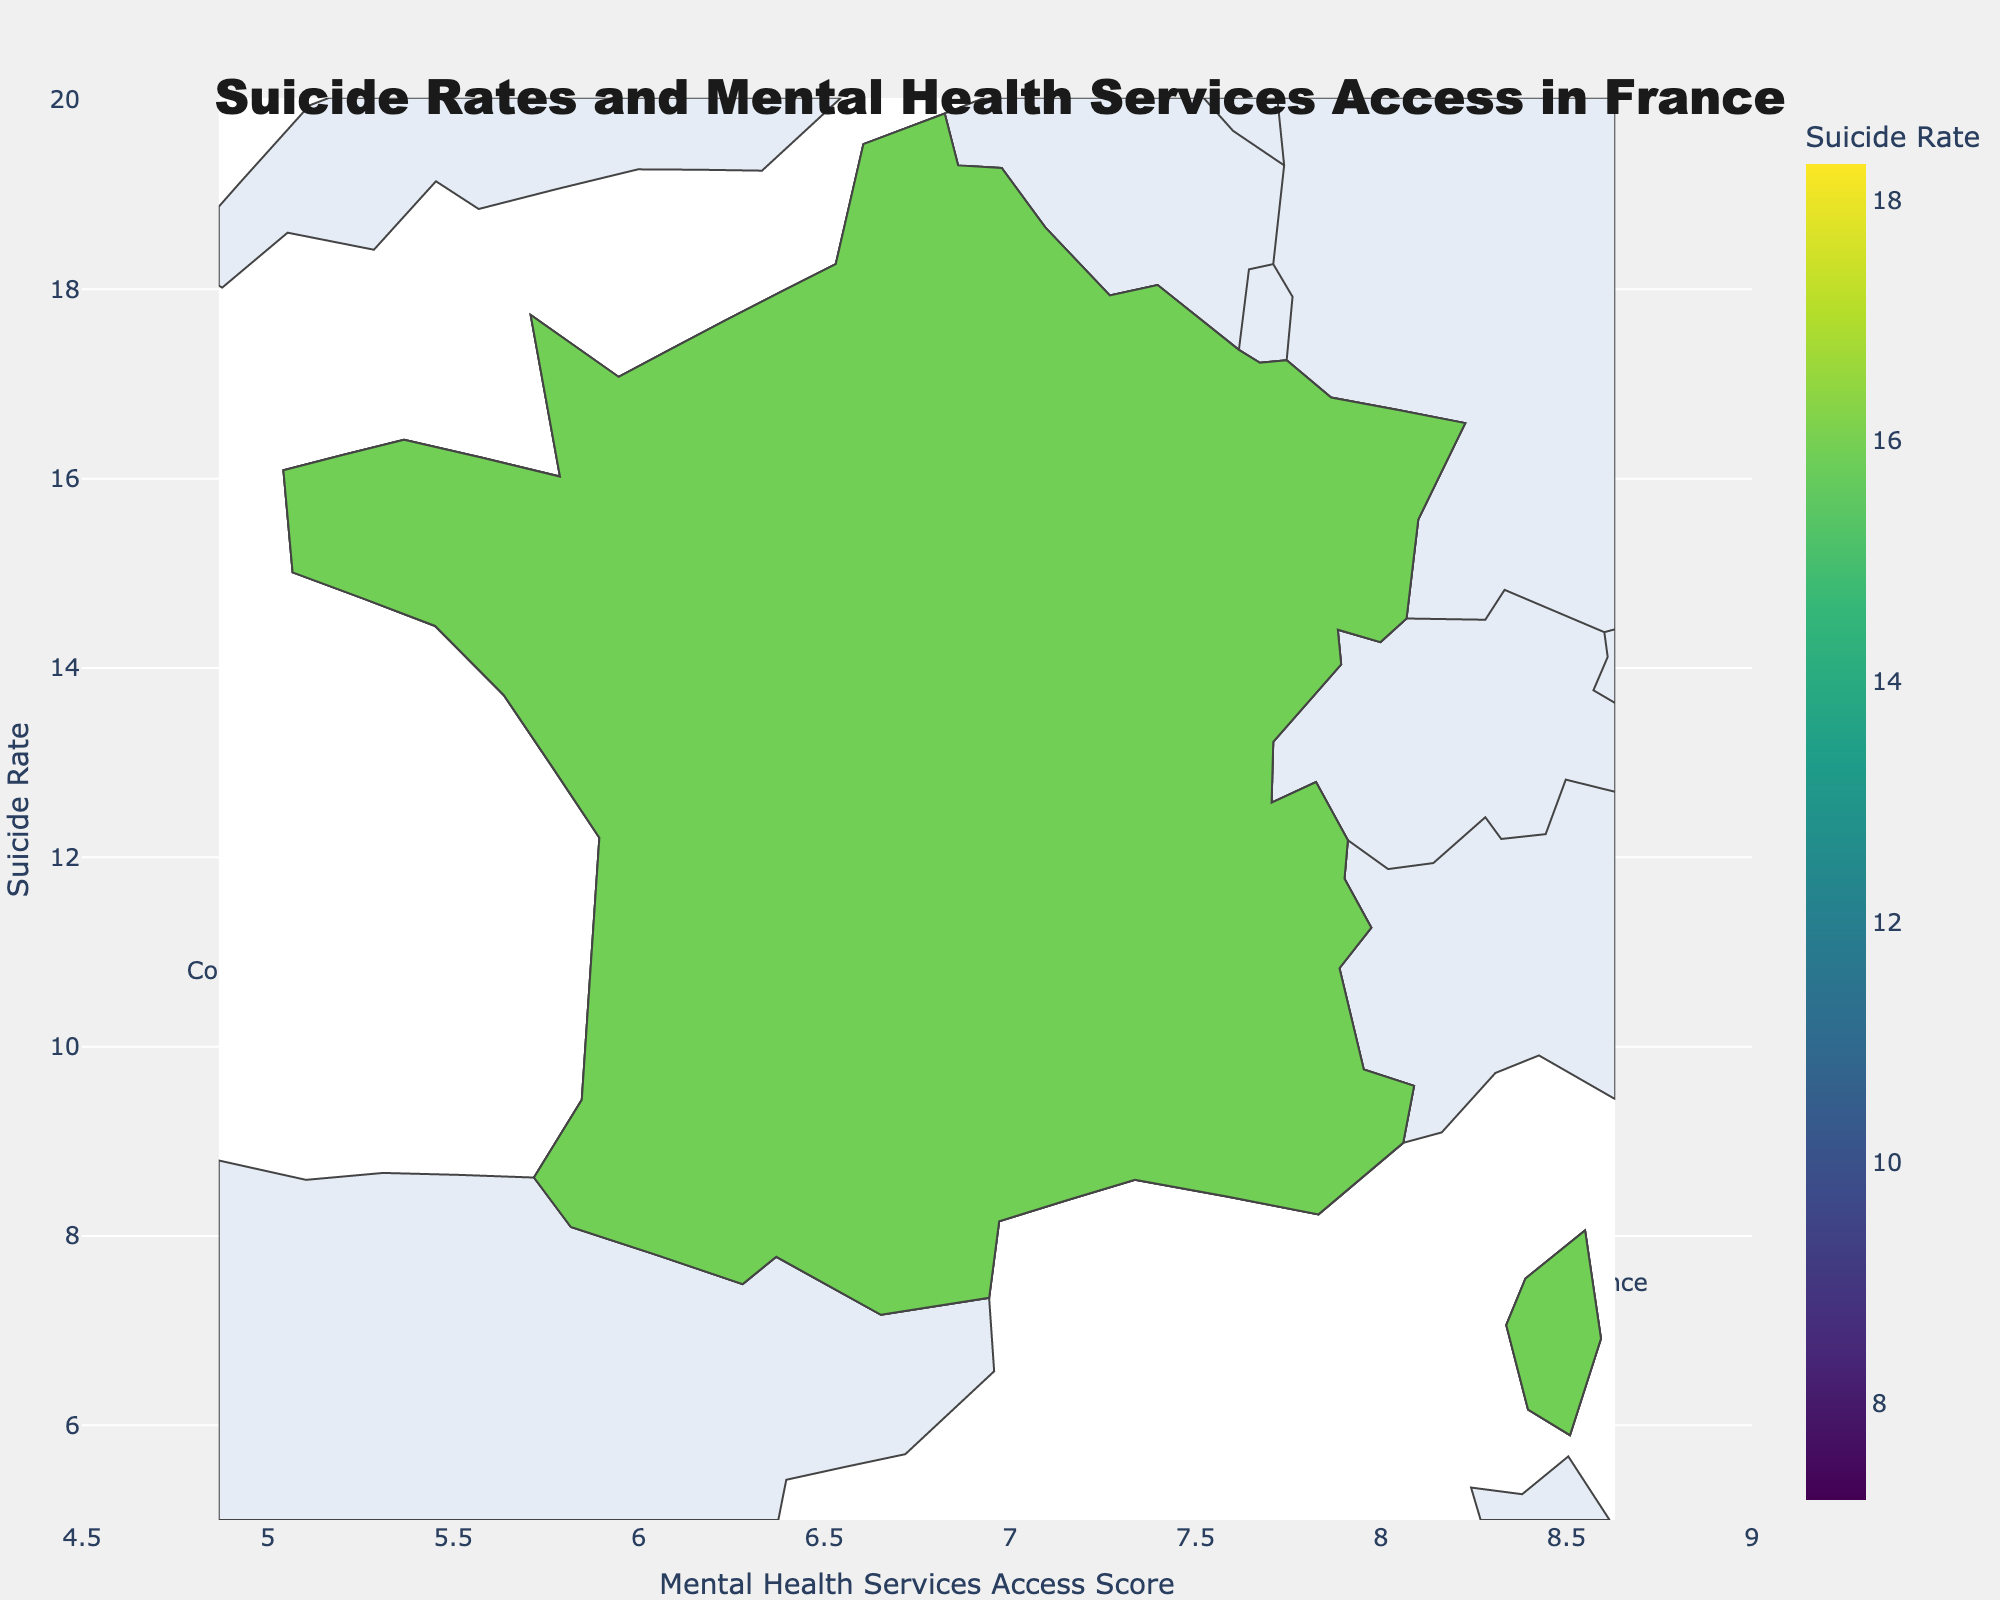What's the title of the figure? The title is one of the most prominent pieces of text in the figure, usually located at the top. It provides a summary of what the figure is about.
Answer: Suicide Rates and Mental Health Services Access in France Which region has the highest suicide rate? By examining the color scale in the choropleth map and looking for the darkest shade, which indicates the highest value, we identify the region with the highest suicide rate.
Answer: Brittany What is the suicide rate in Île-de-France? Find Île-de-France on the map and hover over it (or check the textual data provided) to see its suicide rate.
Answer: 7.2 Which regions have a suicide rate higher than 15? Compare the suicide rates of each region against 15. Regions with suicide rates higher than 15 are highlighted.
Answer: Hauts-de-France, Normandy, Brittany, Centre-Val de Loire Is there a correlation between suicide rates and mental health services access scores in any regions? Inspect the scatter plot to determine if there's any visible pattern (e.g., regions with higher access scores having lower or higher suicide rates).
Answer: Regions with higher mental health services access scores tend to have lower suicide rates, but it's not a strong correlation How does the mental health services access score in Corsica compare to the rest of France? Compare Corsica's mental health services access score with those of other regions. Corsica is among the lower scores based on the scatter plot.
Answer: Lower Which region has the lowest mental health services access score and what is it? Locate the region with the smallest number in the scatter plot or textual data provided.
Answer: Corsica, 4.9 Which region has similar suicide and mental health services access scores? Compare regions' data points to identify any with similar values.
Answer: Occitanie and Bourgogne-Franche-Comté What is the average suicide rate across all regions? Sum all the suicide rates and divide by the number of regions. (7.2 + 12.8 + 14.5 + 15.9 + 13.7 + 11.8 + 13.2 + 16.1 + 18.3 + 14.9 + 15.5 + 14.1 + 10.5) / 13
Answer: 13.7 Which region has the highest suicide rate but a relatively high mental health services access score? Look for the region with the highest suicide rate and then check if it has an access score above the median value. Brittany has the highest suicide rate, but Île-de-France has the highest access score, so they do not match the criteria together.
Answer: None 